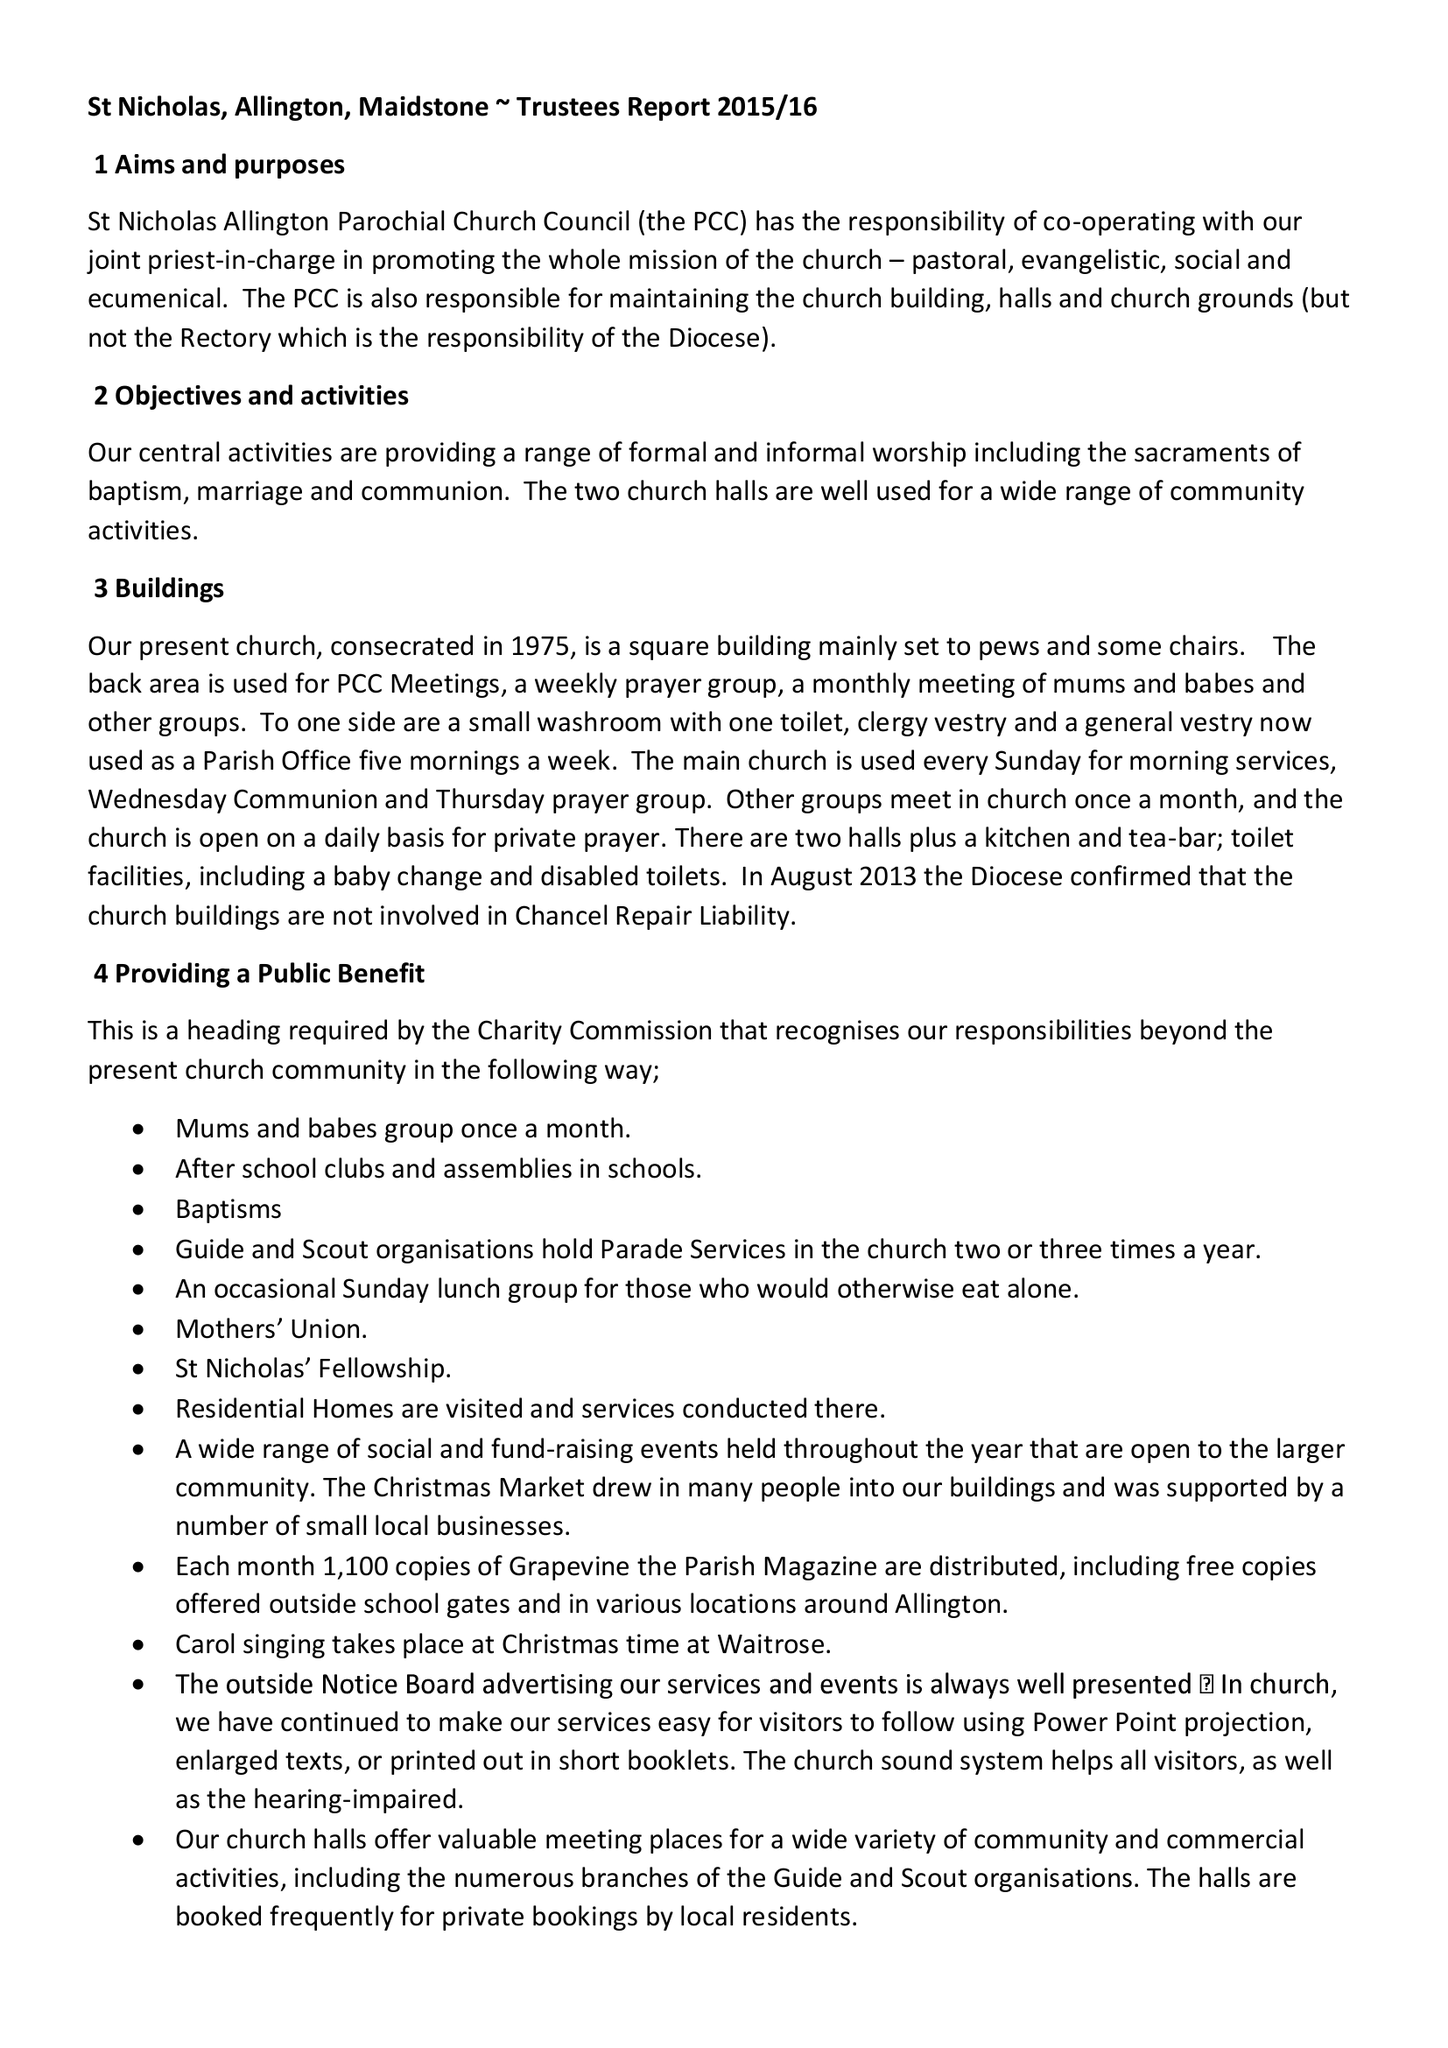What is the value for the income_annually_in_british_pounds?
Answer the question using a single word or phrase. 117627.00 